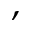Convert formula to latex. <formula><loc_0><loc_0><loc_500><loc_500>,</formula> 